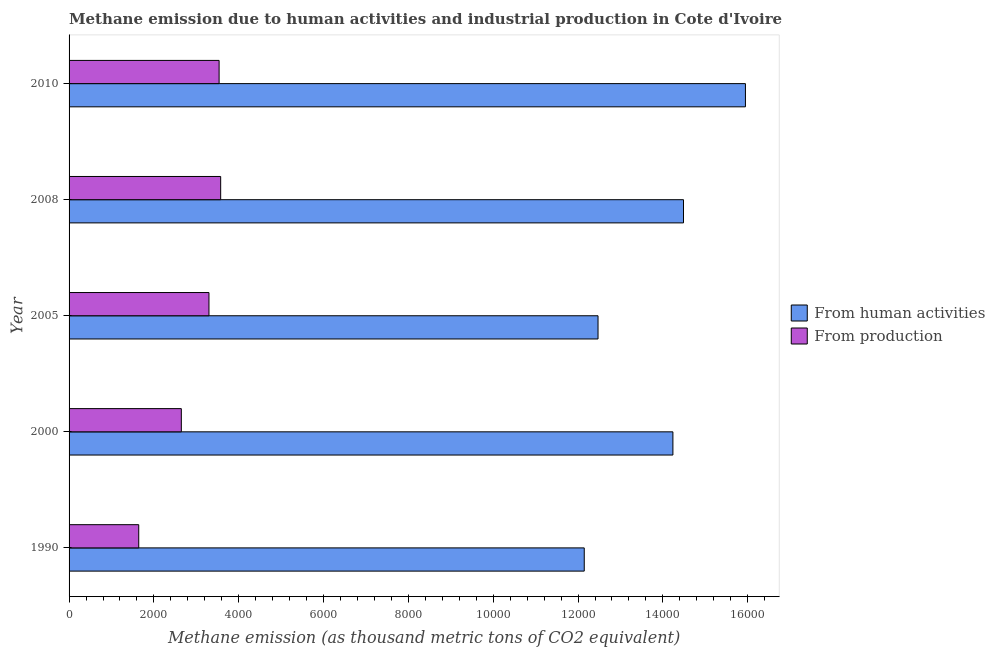Are the number of bars per tick equal to the number of legend labels?
Provide a short and direct response. Yes. How many bars are there on the 5th tick from the bottom?
Your answer should be compact. 2. What is the amount of emissions from human activities in 2000?
Your answer should be very brief. 1.42e+04. Across all years, what is the maximum amount of emissions generated from industries?
Your response must be concise. 3574.4. Across all years, what is the minimum amount of emissions generated from industries?
Give a very brief answer. 1642.3. In which year was the amount of emissions from human activities maximum?
Your answer should be very brief. 2010. In which year was the amount of emissions from human activities minimum?
Provide a short and direct response. 1990. What is the total amount of emissions from human activities in the graph?
Your answer should be very brief. 6.93e+04. What is the difference between the amount of emissions generated from industries in 2005 and that in 2010?
Keep it short and to the point. -239.1. What is the difference between the amount of emissions generated from industries in 2005 and the amount of emissions from human activities in 2010?
Your answer should be compact. -1.26e+04. What is the average amount of emissions generated from industries per year?
Provide a short and direct response. 2939.78. In the year 2000, what is the difference between the amount of emissions generated from industries and amount of emissions from human activities?
Your response must be concise. -1.16e+04. In how many years, is the amount of emissions generated from industries greater than 10000 thousand metric tons?
Provide a succinct answer. 0. What is the difference between the highest and the second highest amount of emissions generated from industries?
Offer a terse response. 37.1. What is the difference between the highest and the lowest amount of emissions generated from industries?
Make the answer very short. 1932.1. In how many years, is the amount of emissions generated from industries greater than the average amount of emissions generated from industries taken over all years?
Offer a terse response. 3. Is the sum of the amount of emissions from human activities in 2000 and 2008 greater than the maximum amount of emissions generated from industries across all years?
Offer a terse response. Yes. What does the 2nd bar from the top in 2005 represents?
Your answer should be very brief. From human activities. What does the 1st bar from the bottom in 2000 represents?
Give a very brief answer. From human activities. Are all the bars in the graph horizontal?
Your answer should be very brief. Yes. How many years are there in the graph?
Offer a terse response. 5. Are the values on the major ticks of X-axis written in scientific E-notation?
Your answer should be compact. No. Does the graph contain any zero values?
Offer a terse response. No. Where does the legend appear in the graph?
Provide a short and direct response. Center right. How many legend labels are there?
Your answer should be compact. 2. What is the title of the graph?
Make the answer very short. Methane emission due to human activities and industrial production in Cote d'Ivoire. Does "Female entrants" appear as one of the legend labels in the graph?
Your response must be concise. No. What is the label or title of the X-axis?
Ensure brevity in your answer.  Methane emission (as thousand metric tons of CO2 equivalent). What is the label or title of the Y-axis?
Your answer should be very brief. Year. What is the Methane emission (as thousand metric tons of CO2 equivalent) in From human activities in 1990?
Give a very brief answer. 1.21e+04. What is the Methane emission (as thousand metric tons of CO2 equivalent) of From production in 1990?
Make the answer very short. 1642.3. What is the Methane emission (as thousand metric tons of CO2 equivalent) of From human activities in 2000?
Give a very brief answer. 1.42e+04. What is the Methane emission (as thousand metric tons of CO2 equivalent) of From production in 2000?
Offer a very short reply. 2646.7. What is the Methane emission (as thousand metric tons of CO2 equivalent) of From human activities in 2005?
Your answer should be very brief. 1.25e+04. What is the Methane emission (as thousand metric tons of CO2 equivalent) of From production in 2005?
Provide a succinct answer. 3298.2. What is the Methane emission (as thousand metric tons of CO2 equivalent) of From human activities in 2008?
Keep it short and to the point. 1.45e+04. What is the Methane emission (as thousand metric tons of CO2 equivalent) of From production in 2008?
Provide a succinct answer. 3574.4. What is the Methane emission (as thousand metric tons of CO2 equivalent) of From human activities in 2010?
Provide a short and direct response. 1.59e+04. What is the Methane emission (as thousand metric tons of CO2 equivalent) in From production in 2010?
Your answer should be compact. 3537.3. Across all years, what is the maximum Methane emission (as thousand metric tons of CO2 equivalent) of From human activities?
Your answer should be compact. 1.59e+04. Across all years, what is the maximum Methane emission (as thousand metric tons of CO2 equivalent) of From production?
Your answer should be very brief. 3574.4. Across all years, what is the minimum Methane emission (as thousand metric tons of CO2 equivalent) of From human activities?
Keep it short and to the point. 1.21e+04. Across all years, what is the minimum Methane emission (as thousand metric tons of CO2 equivalent) of From production?
Keep it short and to the point. 1642.3. What is the total Methane emission (as thousand metric tons of CO2 equivalent) in From human activities in the graph?
Offer a very short reply. 6.93e+04. What is the total Methane emission (as thousand metric tons of CO2 equivalent) in From production in the graph?
Your answer should be very brief. 1.47e+04. What is the difference between the Methane emission (as thousand metric tons of CO2 equivalent) of From human activities in 1990 and that in 2000?
Your response must be concise. -2090.5. What is the difference between the Methane emission (as thousand metric tons of CO2 equivalent) in From production in 1990 and that in 2000?
Your answer should be compact. -1004.4. What is the difference between the Methane emission (as thousand metric tons of CO2 equivalent) of From human activities in 1990 and that in 2005?
Make the answer very short. -325.2. What is the difference between the Methane emission (as thousand metric tons of CO2 equivalent) in From production in 1990 and that in 2005?
Keep it short and to the point. -1655.9. What is the difference between the Methane emission (as thousand metric tons of CO2 equivalent) of From human activities in 1990 and that in 2008?
Offer a very short reply. -2340.3. What is the difference between the Methane emission (as thousand metric tons of CO2 equivalent) of From production in 1990 and that in 2008?
Your answer should be very brief. -1932.1. What is the difference between the Methane emission (as thousand metric tons of CO2 equivalent) of From human activities in 1990 and that in 2010?
Provide a succinct answer. -3800.5. What is the difference between the Methane emission (as thousand metric tons of CO2 equivalent) of From production in 1990 and that in 2010?
Keep it short and to the point. -1895. What is the difference between the Methane emission (as thousand metric tons of CO2 equivalent) in From human activities in 2000 and that in 2005?
Your answer should be very brief. 1765.3. What is the difference between the Methane emission (as thousand metric tons of CO2 equivalent) in From production in 2000 and that in 2005?
Give a very brief answer. -651.5. What is the difference between the Methane emission (as thousand metric tons of CO2 equivalent) of From human activities in 2000 and that in 2008?
Give a very brief answer. -249.8. What is the difference between the Methane emission (as thousand metric tons of CO2 equivalent) in From production in 2000 and that in 2008?
Keep it short and to the point. -927.7. What is the difference between the Methane emission (as thousand metric tons of CO2 equivalent) in From human activities in 2000 and that in 2010?
Keep it short and to the point. -1710. What is the difference between the Methane emission (as thousand metric tons of CO2 equivalent) in From production in 2000 and that in 2010?
Ensure brevity in your answer.  -890.6. What is the difference between the Methane emission (as thousand metric tons of CO2 equivalent) in From human activities in 2005 and that in 2008?
Your response must be concise. -2015.1. What is the difference between the Methane emission (as thousand metric tons of CO2 equivalent) in From production in 2005 and that in 2008?
Keep it short and to the point. -276.2. What is the difference between the Methane emission (as thousand metric tons of CO2 equivalent) of From human activities in 2005 and that in 2010?
Make the answer very short. -3475.3. What is the difference between the Methane emission (as thousand metric tons of CO2 equivalent) of From production in 2005 and that in 2010?
Offer a very short reply. -239.1. What is the difference between the Methane emission (as thousand metric tons of CO2 equivalent) in From human activities in 2008 and that in 2010?
Make the answer very short. -1460.2. What is the difference between the Methane emission (as thousand metric tons of CO2 equivalent) of From production in 2008 and that in 2010?
Provide a succinct answer. 37.1. What is the difference between the Methane emission (as thousand metric tons of CO2 equivalent) in From human activities in 1990 and the Methane emission (as thousand metric tons of CO2 equivalent) in From production in 2000?
Offer a terse response. 9499.6. What is the difference between the Methane emission (as thousand metric tons of CO2 equivalent) in From human activities in 1990 and the Methane emission (as thousand metric tons of CO2 equivalent) in From production in 2005?
Your answer should be compact. 8848.1. What is the difference between the Methane emission (as thousand metric tons of CO2 equivalent) in From human activities in 1990 and the Methane emission (as thousand metric tons of CO2 equivalent) in From production in 2008?
Ensure brevity in your answer.  8571.9. What is the difference between the Methane emission (as thousand metric tons of CO2 equivalent) in From human activities in 1990 and the Methane emission (as thousand metric tons of CO2 equivalent) in From production in 2010?
Provide a short and direct response. 8609. What is the difference between the Methane emission (as thousand metric tons of CO2 equivalent) in From human activities in 2000 and the Methane emission (as thousand metric tons of CO2 equivalent) in From production in 2005?
Offer a very short reply. 1.09e+04. What is the difference between the Methane emission (as thousand metric tons of CO2 equivalent) in From human activities in 2000 and the Methane emission (as thousand metric tons of CO2 equivalent) in From production in 2008?
Give a very brief answer. 1.07e+04. What is the difference between the Methane emission (as thousand metric tons of CO2 equivalent) of From human activities in 2000 and the Methane emission (as thousand metric tons of CO2 equivalent) of From production in 2010?
Your answer should be very brief. 1.07e+04. What is the difference between the Methane emission (as thousand metric tons of CO2 equivalent) of From human activities in 2005 and the Methane emission (as thousand metric tons of CO2 equivalent) of From production in 2008?
Offer a terse response. 8897.1. What is the difference between the Methane emission (as thousand metric tons of CO2 equivalent) of From human activities in 2005 and the Methane emission (as thousand metric tons of CO2 equivalent) of From production in 2010?
Provide a succinct answer. 8934.2. What is the difference between the Methane emission (as thousand metric tons of CO2 equivalent) in From human activities in 2008 and the Methane emission (as thousand metric tons of CO2 equivalent) in From production in 2010?
Your answer should be very brief. 1.09e+04. What is the average Methane emission (as thousand metric tons of CO2 equivalent) in From human activities per year?
Provide a short and direct response. 1.39e+04. What is the average Methane emission (as thousand metric tons of CO2 equivalent) of From production per year?
Offer a terse response. 2939.78. In the year 1990, what is the difference between the Methane emission (as thousand metric tons of CO2 equivalent) of From human activities and Methane emission (as thousand metric tons of CO2 equivalent) of From production?
Your answer should be very brief. 1.05e+04. In the year 2000, what is the difference between the Methane emission (as thousand metric tons of CO2 equivalent) of From human activities and Methane emission (as thousand metric tons of CO2 equivalent) of From production?
Offer a terse response. 1.16e+04. In the year 2005, what is the difference between the Methane emission (as thousand metric tons of CO2 equivalent) of From human activities and Methane emission (as thousand metric tons of CO2 equivalent) of From production?
Give a very brief answer. 9173.3. In the year 2008, what is the difference between the Methane emission (as thousand metric tons of CO2 equivalent) in From human activities and Methane emission (as thousand metric tons of CO2 equivalent) in From production?
Offer a very short reply. 1.09e+04. In the year 2010, what is the difference between the Methane emission (as thousand metric tons of CO2 equivalent) of From human activities and Methane emission (as thousand metric tons of CO2 equivalent) of From production?
Your answer should be compact. 1.24e+04. What is the ratio of the Methane emission (as thousand metric tons of CO2 equivalent) of From human activities in 1990 to that in 2000?
Your response must be concise. 0.85. What is the ratio of the Methane emission (as thousand metric tons of CO2 equivalent) in From production in 1990 to that in 2000?
Your answer should be compact. 0.62. What is the ratio of the Methane emission (as thousand metric tons of CO2 equivalent) in From human activities in 1990 to that in 2005?
Offer a terse response. 0.97. What is the ratio of the Methane emission (as thousand metric tons of CO2 equivalent) in From production in 1990 to that in 2005?
Provide a succinct answer. 0.5. What is the ratio of the Methane emission (as thousand metric tons of CO2 equivalent) in From human activities in 1990 to that in 2008?
Offer a very short reply. 0.84. What is the ratio of the Methane emission (as thousand metric tons of CO2 equivalent) of From production in 1990 to that in 2008?
Provide a short and direct response. 0.46. What is the ratio of the Methane emission (as thousand metric tons of CO2 equivalent) in From human activities in 1990 to that in 2010?
Your answer should be compact. 0.76. What is the ratio of the Methane emission (as thousand metric tons of CO2 equivalent) of From production in 1990 to that in 2010?
Give a very brief answer. 0.46. What is the ratio of the Methane emission (as thousand metric tons of CO2 equivalent) of From human activities in 2000 to that in 2005?
Your answer should be compact. 1.14. What is the ratio of the Methane emission (as thousand metric tons of CO2 equivalent) in From production in 2000 to that in 2005?
Make the answer very short. 0.8. What is the ratio of the Methane emission (as thousand metric tons of CO2 equivalent) in From human activities in 2000 to that in 2008?
Your response must be concise. 0.98. What is the ratio of the Methane emission (as thousand metric tons of CO2 equivalent) of From production in 2000 to that in 2008?
Your response must be concise. 0.74. What is the ratio of the Methane emission (as thousand metric tons of CO2 equivalent) of From human activities in 2000 to that in 2010?
Make the answer very short. 0.89. What is the ratio of the Methane emission (as thousand metric tons of CO2 equivalent) of From production in 2000 to that in 2010?
Provide a succinct answer. 0.75. What is the ratio of the Methane emission (as thousand metric tons of CO2 equivalent) in From human activities in 2005 to that in 2008?
Offer a terse response. 0.86. What is the ratio of the Methane emission (as thousand metric tons of CO2 equivalent) in From production in 2005 to that in 2008?
Your answer should be compact. 0.92. What is the ratio of the Methane emission (as thousand metric tons of CO2 equivalent) of From human activities in 2005 to that in 2010?
Your answer should be very brief. 0.78. What is the ratio of the Methane emission (as thousand metric tons of CO2 equivalent) in From production in 2005 to that in 2010?
Offer a terse response. 0.93. What is the ratio of the Methane emission (as thousand metric tons of CO2 equivalent) of From human activities in 2008 to that in 2010?
Provide a succinct answer. 0.91. What is the ratio of the Methane emission (as thousand metric tons of CO2 equivalent) in From production in 2008 to that in 2010?
Your answer should be compact. 1.01. What is the difference between the highest and the second highest Methane emission (as thousand metric tons of CO2 equivalent) in From human activities?
Ensure brevity in your answer.  1460.2. What is the difference between the highest and the second highest Methane emission (as thousand metric tons of CO2 equivalent) in From production?
Provide a succinct answer. 37.1. What is the difference between the highest and the lowest Methane emission (as thousand metric tons of CO2 equivalent) of From human activities?
Offer a very short reply. 3800.5. What is the difference between the highest and the lowest Methane emission (as thousand metric tons of CO2 equivalent) in From production?
Offer a terse response. 1932.1. 